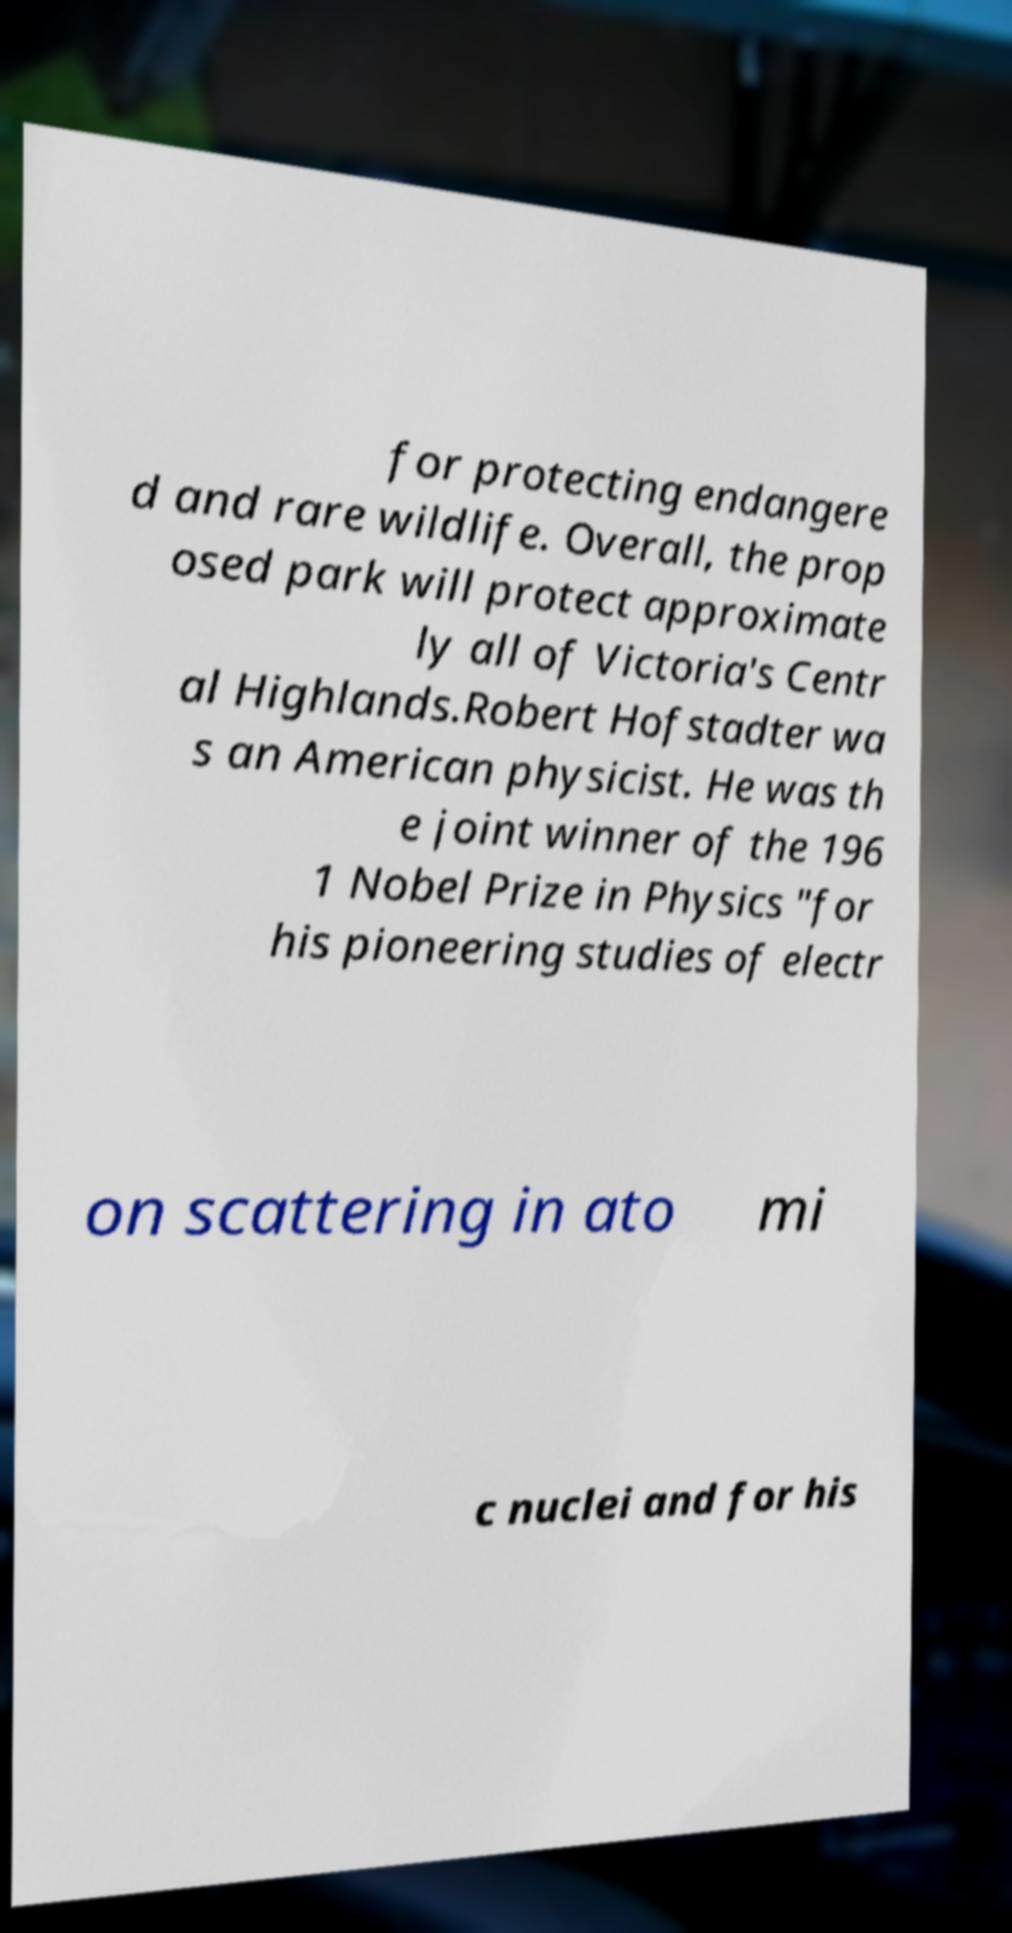For documentation purposes, I need the text within this image transcribed. Could you provide that? for protecting endangere d and rare wildlife. Overall, the prop osed park will protect approximate ly all of Victoria's Centr al Highlands.Robert Hofstadter wa s an American physicist. He was th e joint winner of the 196 1 Nobel Prize in Physics "for his pioneering studies of electr on scattering in ato mi c nuclei and for his 